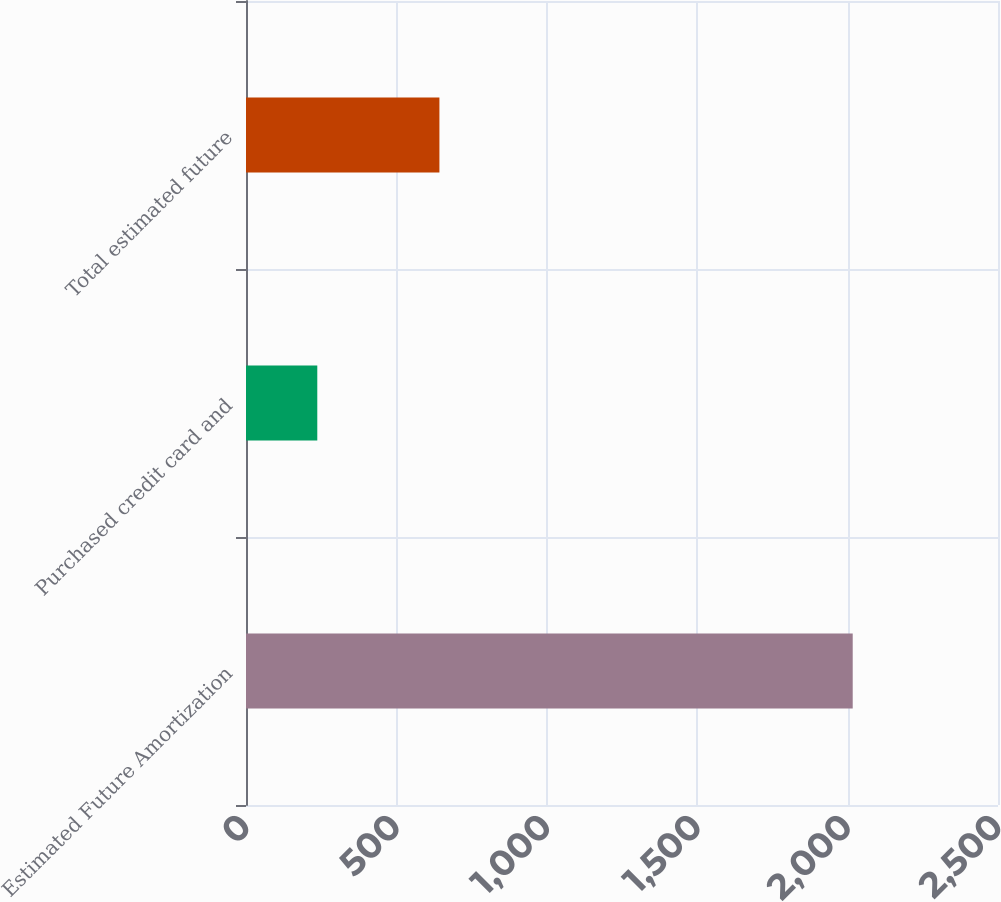Convert chart to OTSL. <chart><loc_0><loc_0><loc_500><loc_500><bar_chart><fcel>Estimated Future Amortization<fcel>Purchased credit card and<fcel>Total estimated future<nl><fcel>2017<fcel>237<fcel>643<nl></chart> 